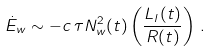Convert formula to latex. <formula><loc_0><loc_0><loc_500><loc_500>\dot { E } _ { w } \sim - c \, \tau N ^ { 2 } _ { w } ( t ) \left ( \frac { L _ { l } ( t ) } { R ( t ) } \right ) \, .</formula> 